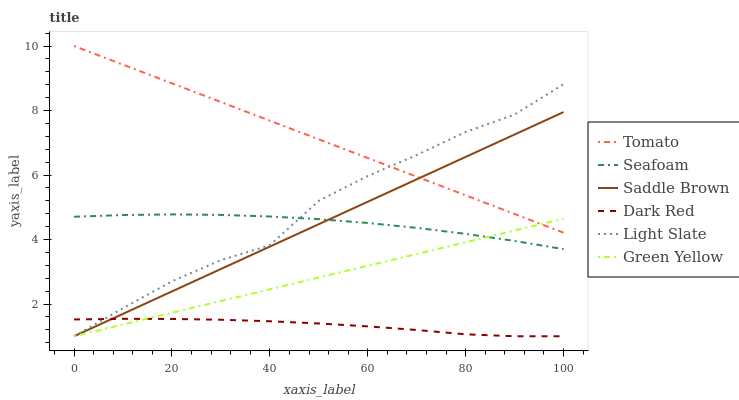Does Dark Red have the minimum area under the curve?
Answer yes or no. Yes. Does Tomato have the maximum area under the curve?
Answer yes or no. Yes. Does Light Slate have the minimum area under the curve?
Answer yes or no. No. Does Light Slate have the maximum area under the curve?
Answer yes or no. No. Is Saddle Brown the smoothest?
Answer yes or no. Yes. Is Light Slate the roughest?
Answer yes or no. Yes. Is Dark Red the smoothest?
Answer yes or no. No. Is Dark Red the roughest?
Answer yes or no. No. Does Light Slate have the lowest value?
Answer yes or no. Yes. Does Seafoam have the lowest value?
Answer yes or no. No. Does Tomato have the highest value?
Answer yes or no. Yes. Does Light Slate have the highest value?
Answer yes or no. No. Is Seafoam less than Tomato?
Answer yes or no. Yes. Is Tomato greater than Dark Red?
Answer yes or no. Yes. Does Tomato intersect Light Slate?
Answer yes or no. Yes. Is Tomato less than Light Slate?
Answer yes or no. No. Is Tomato greater than Light Slate?
Answer yes or no. No. Does Seafoam intersect Tomato?
Answer yes or no. No. 